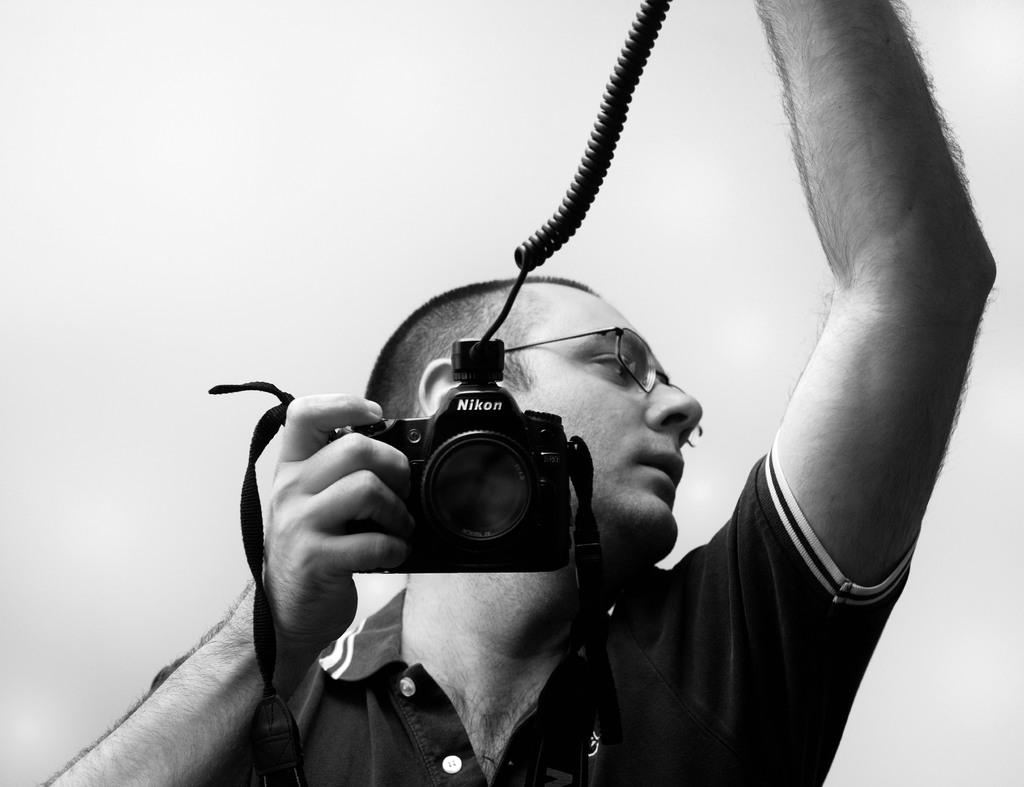What is the main subject of the image? There is a man in the image. What is the man holding in the image? The man is holding a camera. What type of baseball equipment can be seen in the image? There is no baseball equipment present in the image; it features a man holding a camera. What is the man using to comb his hair in the image? There is no comb visible in the image, and the man is not shown grooming his hair. 